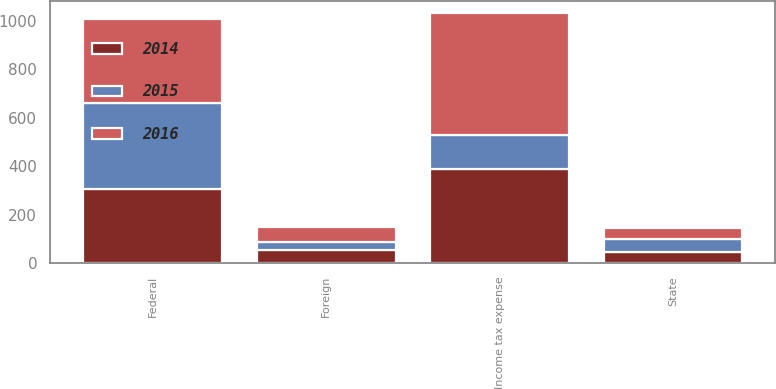Convert chart. <chart><loc_0><loc_0><loc_500><loc_500><stacked_bar_chart><ecel><fcel>Federal<fcel>State<fcel>Foreign<fcel>Income tax expense<nl><fcel>2016<fcel>347<fcel>48<fcel>60<fcel>503<nl><fcel>2015<fcel>354<fcel>51<fcel>33<fcel>141<nl><fcel>2014<fcel>305<fcel>46<fcel>55<fcel>388<nl></chart> 